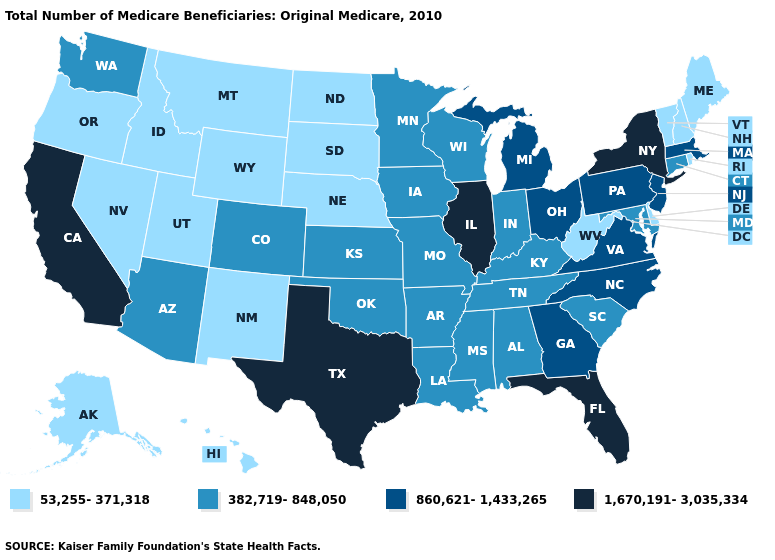Name the states that have a value in the range 1,670,191-3,035,334?
Quick response, please. California, Florida, Illinois, New York, Texas. Name the states that have a value in the range 1,670,191-3,035,334?
Concise answer only. California, Florida, Illinois, New York, Texas. Does New York have the highest value in the Northeast?
Short answer required. Yes. Does New York have a higher value than New Mexico?
Answer briefly. Yes. Which states have the lowest value in the MidWest?
Answer briefly. Nebraska, North Dakota, South Dakota. Does Maine have a lower value than Utah?
Write a very short answer. No. Does Maryland have a lower value than Idaho?
Short answer required. No. Which states have the lowest value in the West?
Give a very brief answer. Alaska, Hawaii, Idaho, Montana, Nevada, New Mexico, Oregon, Utah, Wyoming. Which states have the highest value in the USA?
Quick response, please. California, Florida, Illinois, New York, Texas. What is the value of Utah?
Be succinct. 53,255-371,318. What is the value of North Carolina?
Write a very short answer. 860,621-1,433,265. Name the states that have a value in the range 382,719-848,050?
Give a very brief answer. Alabama, Arizona, Arkansas, Colorado, Connecticut, Indiana, Iowa, Kansas, Kentucky, Louisiana, Maryland, Minnesota, Mississippi, Missouri, Oklahoma, South Carolina, Tennessee, Washington, Wisconsin. Does Iowa have a higher value than Vermont?
Keep it brief. Yes. What is the lowest value in states that border Mississippi?
Give a very brief answer. 382,719-848,050. 